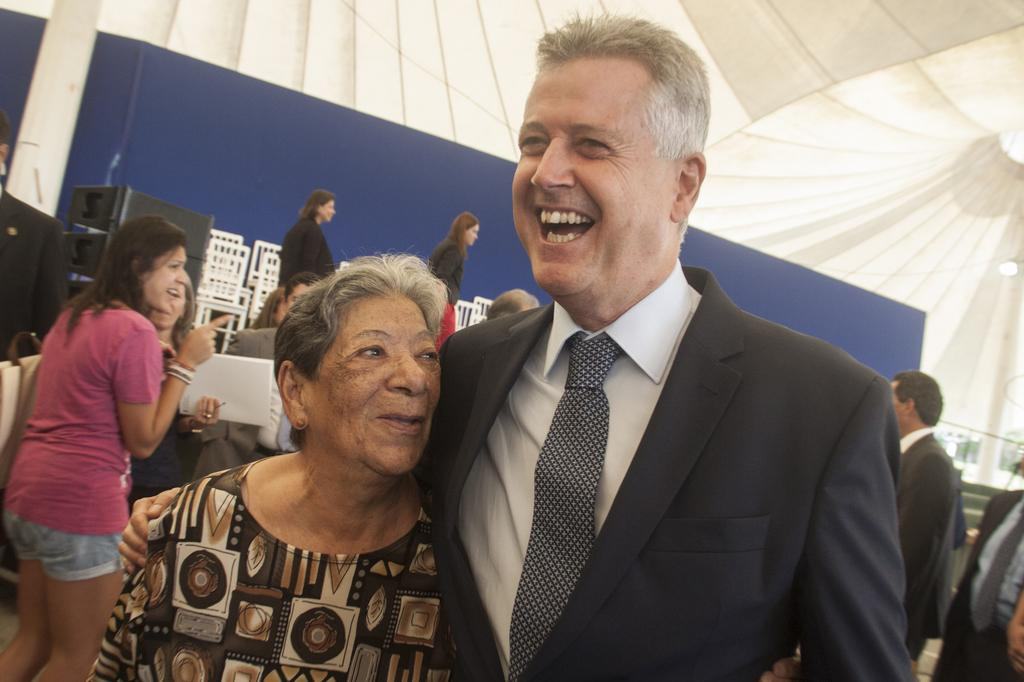Who or what can be seen in the image? There are people in the image. What are the people sitting on in the image? There are chairs in the image. What objects are present that might be used for communication or entertainment? There are devices in the image. What type of temporary shelter is visible in the image? There is a tent in the image. What structures are supporting the tent or other objects in the image? There are poles in the image. What type of coat is being worn by the person playing basketball in the image? There is no person playing basketball in the image, nor is there a coat visible. 